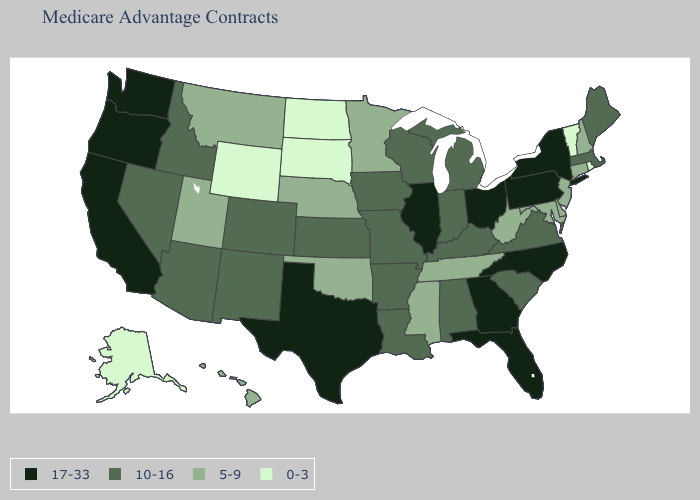What is the value of Nevada?
Keep it brief. 10-16. Name the states that have a value in the range 17-33?
Keep it brief. California, Florida, Georgia, Illinois, North Carolina, New York, Ohio, Oregon, Pennsylvania, Texas, Washington. Does Alaska have the lowest value in the West?
Short answer required. Yes. Does the map have missing data?
Be succinct. No. Name the states that have a value in the range 0-3?
Quick response, please. Alaska, North Dakota, Rhode Island, South Dakota, Vermont, Wyoming. Is the legend a continuous bar?
Quick response, please. No. What is the lowest value in states that border Minnesota?
Give a very brief answer. 0-3. Among the states that border Pennsylvania , which have the highest value?
Quick response, please. New York, Ohio. Does Idaho have a higher value than Alaska?
Be succinct. Yes. What is the value of Alabama?
Answer briefly. 10-16. What is the value of Nevada?
Write a very short answer. 10-16. Which states have the highest value in the USA?
Give a very brief answer. California, Florida, Georgia, Illinois, North Carolina, New York, Ohio, Oregon, Pennsylvania, Texas, Washington. What is the value of Washington?
Give a very brief answer. 17-33. Does the first symbol in the legend represent the smallest category?
Write a very short answer. No. What is the lowest value in the USA?
Quick response, please. 0-3. 